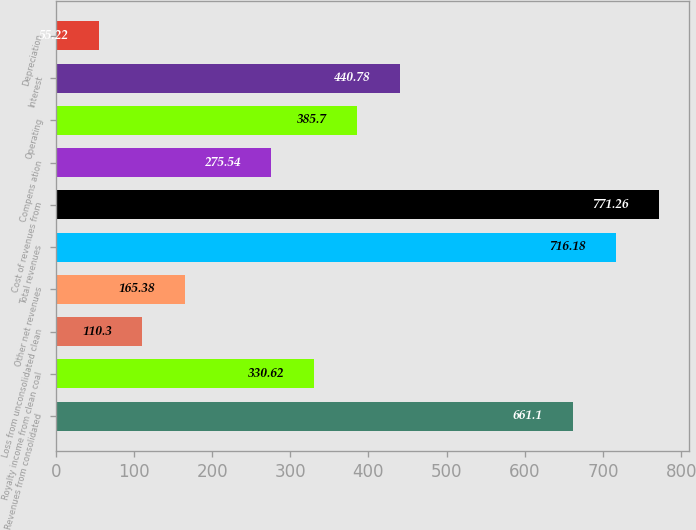Convert chart. <chart><loc_0><loc_0><loc_500><loc_500><bar_chart><fcel>Revenues from consolidated<fcel>Royalty income from clean coal<fcel>Loss from unconsolidated clean<fcel>Other net revenues<fcel>Total revenues<fcel>Cost of revenues from<fcel>Compens ation<fcel>Operating<fcel>Interest<fcel>Depreciation<nl><fcel>661.1<fcel>330.62<fcel>110.3<fcel>165.38<fcel>716.18<fcel>771.26<fcel>275.54<fcel>385.7<fcel>440.78<fcel>55.22<nl></chart> 